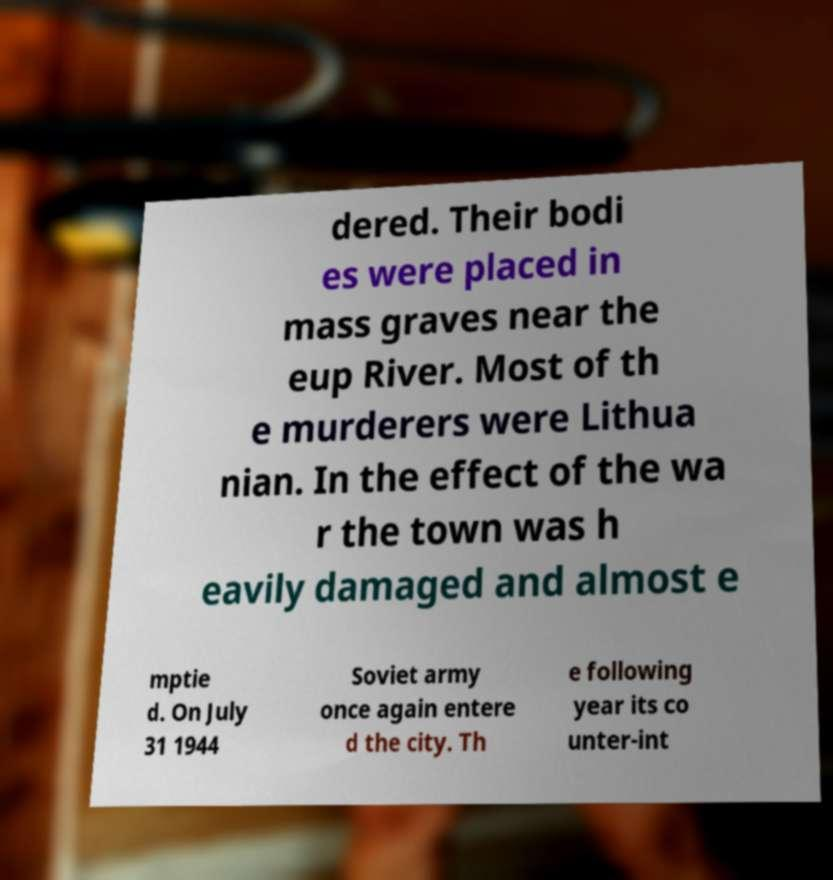I need the written content from this picture converted into text. Can you do that? dered. Their bodi es were placed in mass graves near the eup River. Most of th e murderers were Lithua nian. In the effect of the wa r the town was h eavily damaged and almost e mptie d. On July 31 1944 Soviet army once again entere d the city. Th e following year its co unter-int 